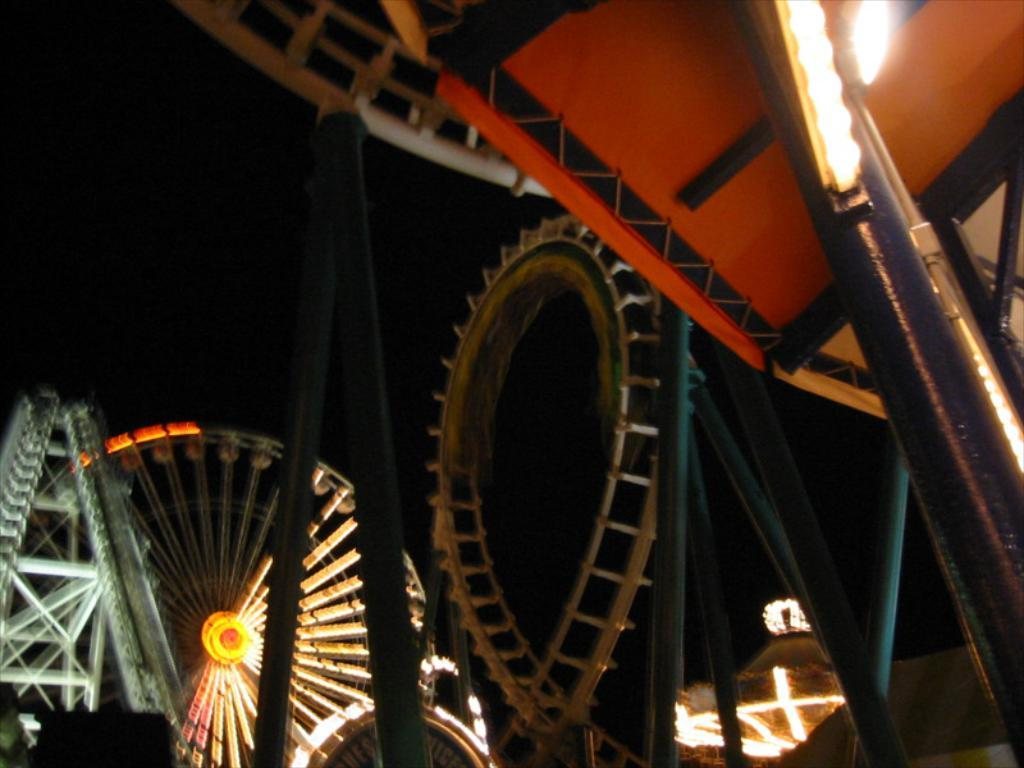What type of location is depicted in the image? A: The image shows an amusement park. What specific features can be seen in the image? There are amusement park rides, rods, and lights visible in the image. How would you describe the lighting conditions in the image? The background of the image is dark. What type of recess can be seen in the image? There is no recess present in the image; it depicts an amusement park with rides, rods, and lights. What form does the amusement park take in the image? The amusement park is depicted as a collection of rides, rods, and lights, but it does not have a specific form or shape in the image. 